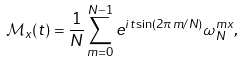<formula> <loc_0><loc_0><loc_500><loc_500>\mathcal { M } _ { x } ( t ) = \frac { 1 } { N } \sum _ { m = 0 } ^ { N - 1 } e ^ { i t \sin ( 2 \pi m / N ) } \omega _ { N } ^ { m x } ,</formula> 